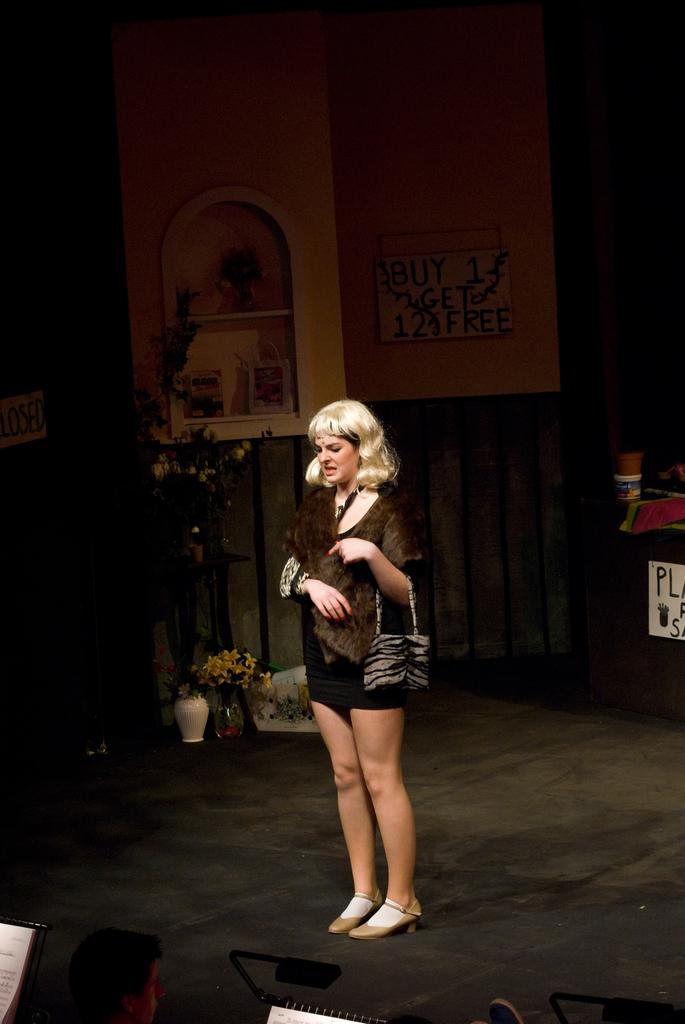What is the main subject in the image? There is a woman standing in the image. Where is the woman standing? The woman is standing on the floor. What can be seen on the left side of the image? There is a plant vase on the left side of the image. What type of furniture is present in the image? There is a rack shelf in the image. What is the material of the wall in the image? There is a wooden wall in the image. What type of cable is used to support the wooden wall in the image? There is no cable mentioned or visible in the image, and the wooden wall is not supported by any cable. 